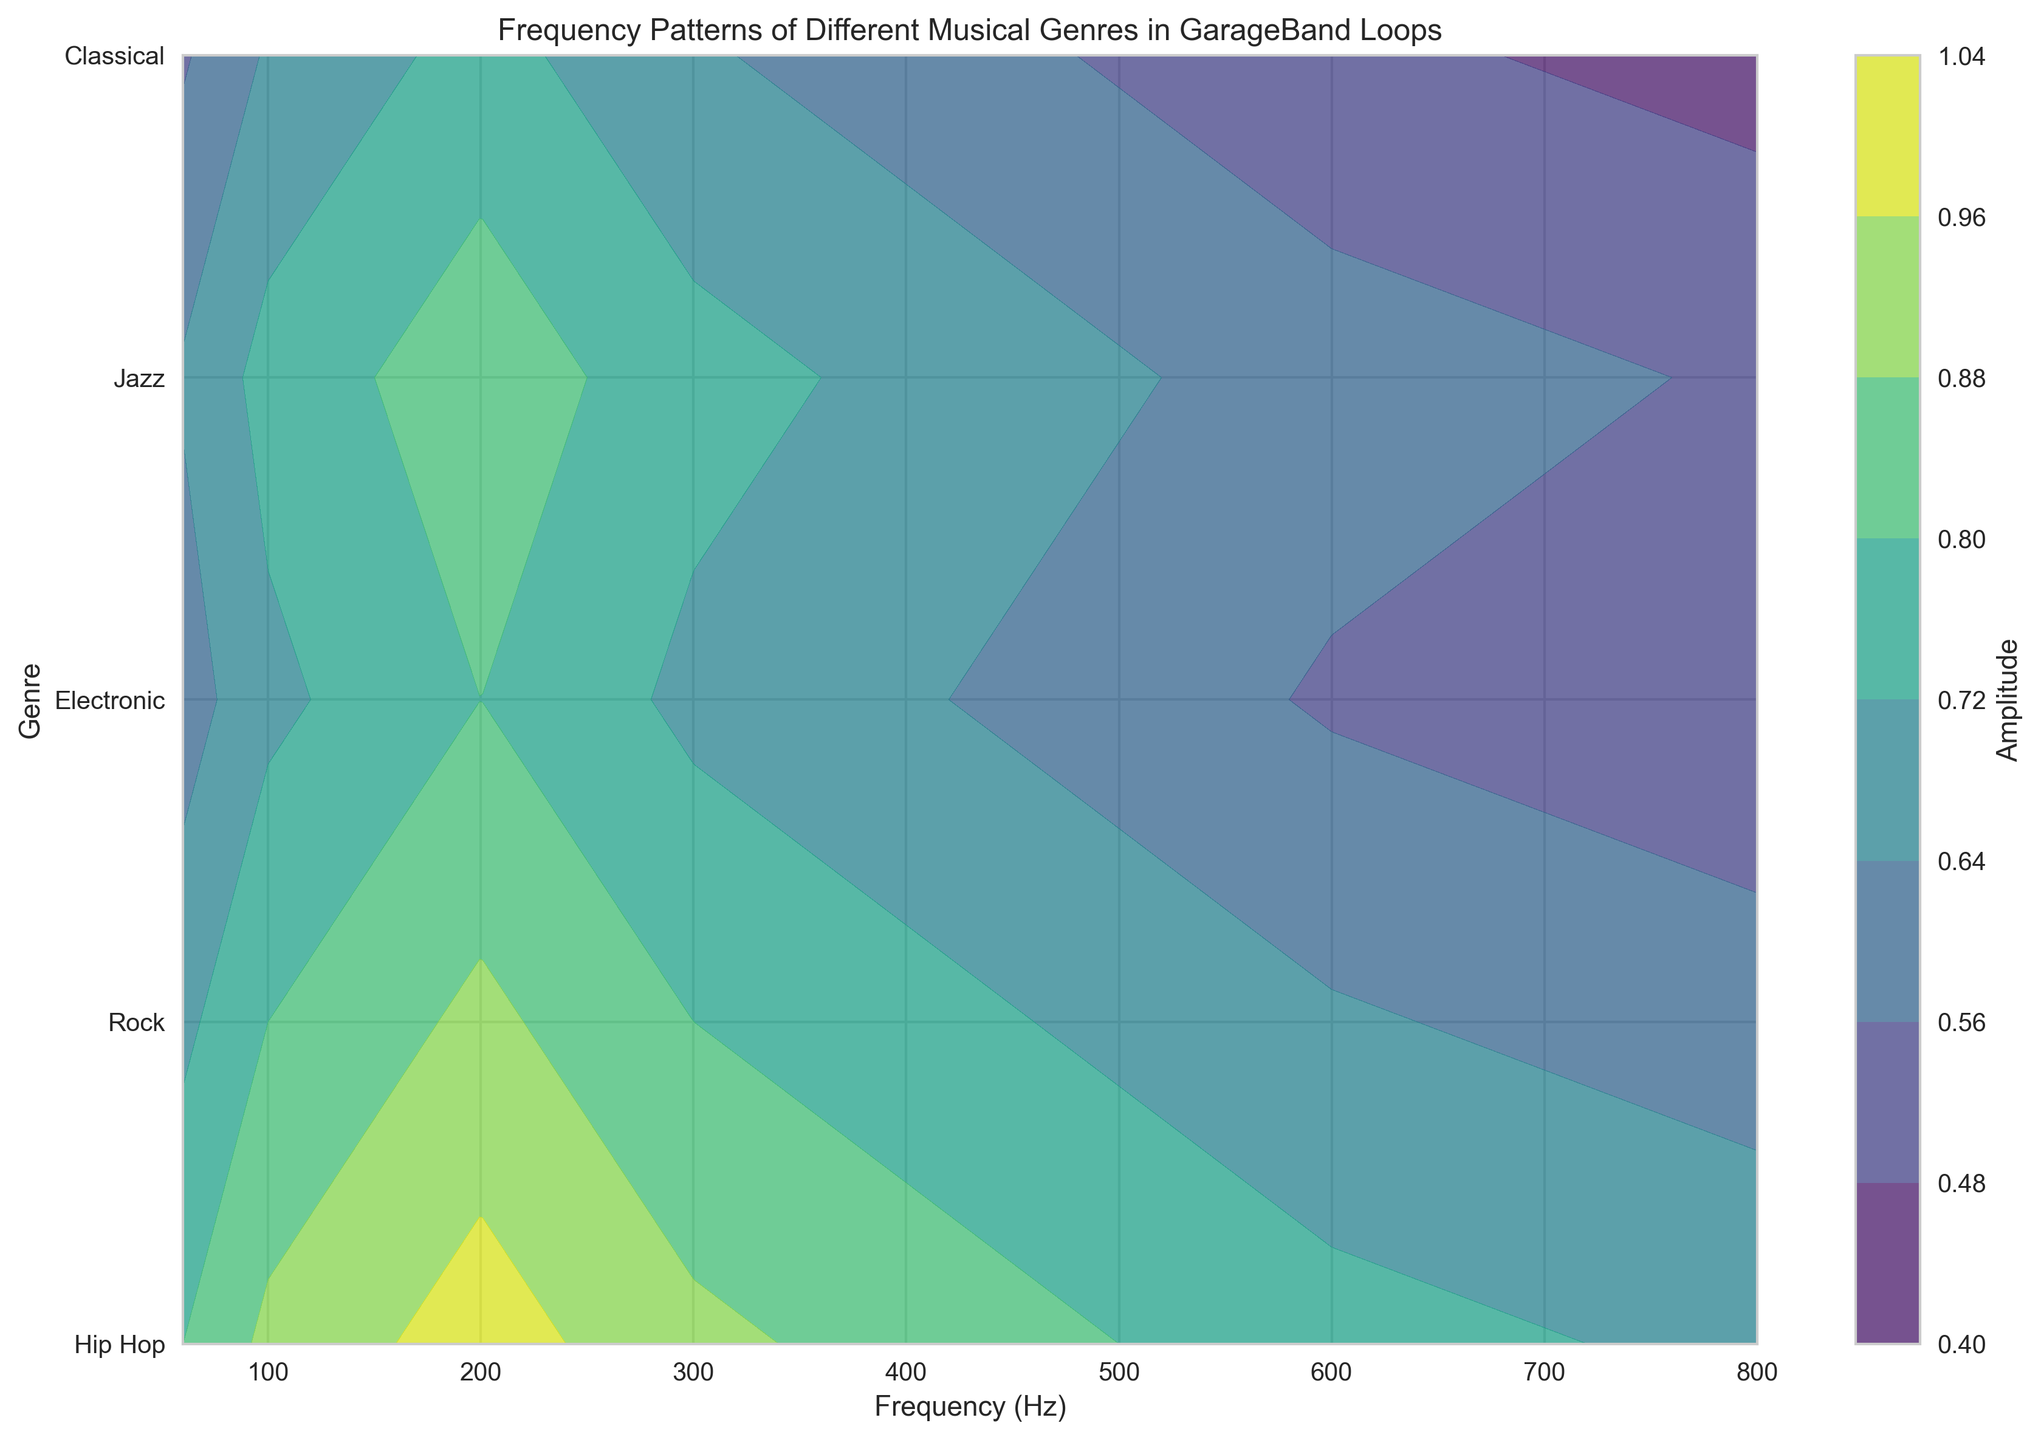Which genre has the highest amplitude at 200 Hz? Look at the 200 Hz frequency line for each genre and find the highest peak. Hip Hop shows the highest amplitude around 200 Hz.
Answer: Hip Hop How does the amplitude of Classical music compare to Jazz music at 400 Hz? Find the amplitude values for Classical and Jazz at 400 Hz. Classical has a lower amplitude compared to Jazz at 400 Hz.
Answer: Jazz is higher At which frequency does Rock music reach its highest amplitude? Inspect the amplitude line for Rock music and identify the peak frequency. The highest amplitude for Rock is at 200 Hz.
Answer: 200 Hz What is the average amplitude of Electronic music between 150 Hz and 300 Hz? Calculate the amplitudes at 150 Hz, 200 Hz, 250 Hz, and 300 Hz for Electronic music and find the mean. (0.75 + 0.8 + 0.75 + 0.7) / 4 = 0.75
Answer: 0.75 Compare the amplitude variation of Hip Hop and Electronic music across the frequency range. Observe the amplitude lines for both genres. Hip Hop shows a significant peak and decline, whereas Electronic music has a more gradual change in amplitude.
Answer: Hip Hop has more variation Which genre maintains a relatively stable amplitude across all frequencies? Look for the genre with the least fluctuations in amplitude. Jazz and Electronic show relatively stable amplitudes but Electronic has less fluctuation.
Answer: Electronic Is the minimum amplitude of Hip Hop greater than the maximum amplitude of Classical? Determine the lowest amplitude of Hip Hop and the highest amplitude of Classical. Hip Hop's minimum amplitude is around 0.7 at high frequencies, whereas Classical's maximum is 0.75.
Answer: No Between Jazz and Rock, which genre has the higher amplitude at 100 Hz? Compare the amplitude values of Jazz and Rock at 100 Hz. Jazz has an amplitude of 0.75, and Rock has 0.8.
Answer: Rock At which frequency do both Jazz and Classical music have the same amplitude? Identify the frequency where both Jazz and Classical have coinciding amplitude values. Both have the same amplitude at 60 Hz with a value of 0.65.
Answer: 60 Hz 